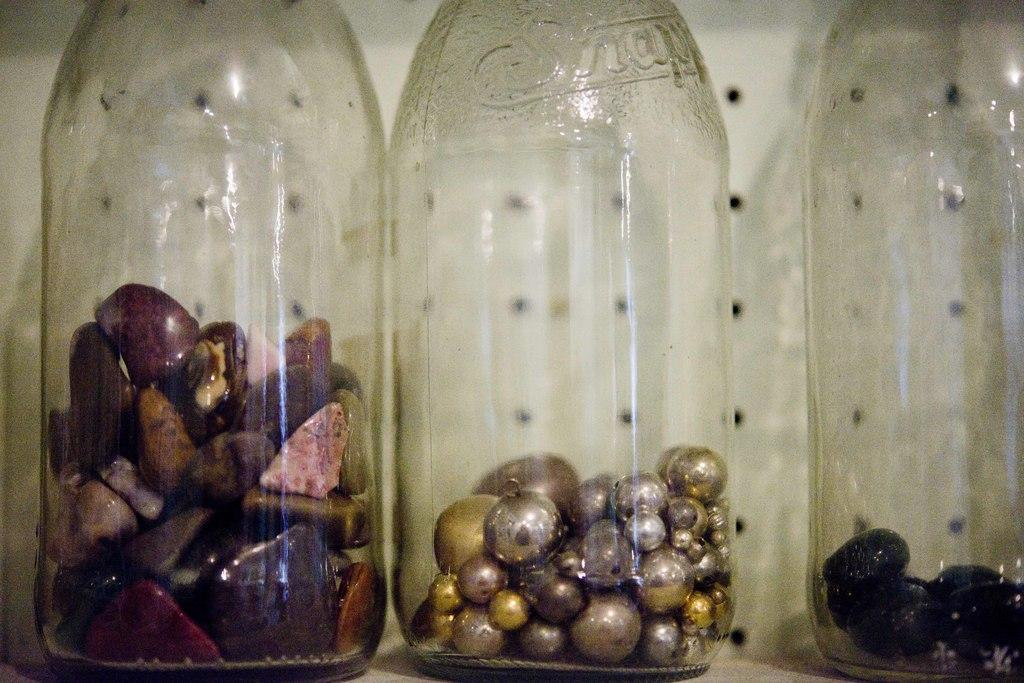How many bottles are visible in the image? There are three bottles in the image. What is inside the bottle on the left side? The bottle on the left side contains stones. What is inside the bottle in the middle? The bottle in the middle contains pearls. What type of ornament is hanging from the neck of the shirt in the image? There is no shirt or ornament present in the image; it only features three bottles with different contents. 